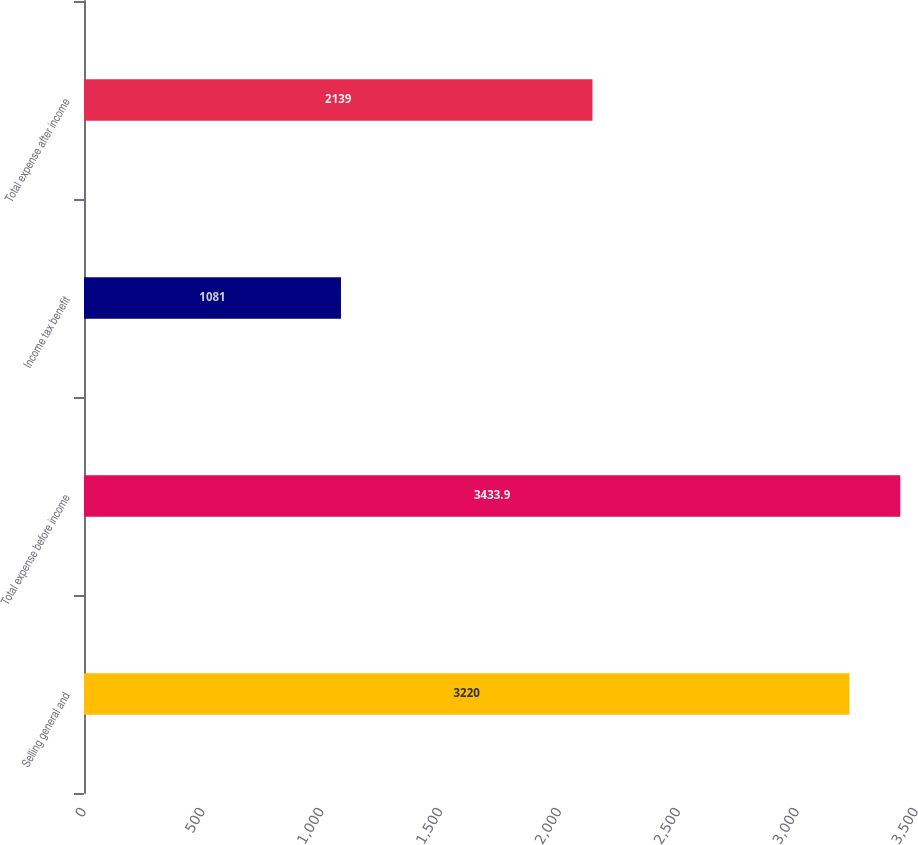<chart> <loc_0><loc_0><loc_500><loc_500><bar_chart><fcel>Selling general and<fcel>Total expense before income<fcel>Income tax benefit<fcel>Total expense after income<nl><fcel>3220<fcel>3433.9<fcel>1081<fcel>2139<nl></chart> 